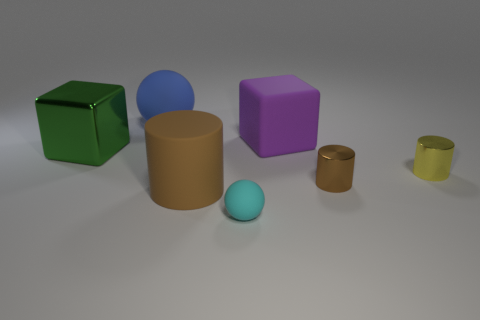Is the number of spheres in front of the large shiny thing greater than the number of big brown objects on the right side of the tiny cyan rubber thing?
Ensure brevity in your answer.  Yes. There is a metallic thing on the left side of the big matte object that is in front of the tiny metallic cylinder in front of the tiny yellow thing; what is its shape?
Provide a short and direct response. Cube. What shape is the thing left of the rubber sphere that is behind the small rubber thing?
Your response must be concise. Cube. Are there any big green objects that have the same material as the large ball?
Offer a very short reply. No. What size is the shiny thing that is the same color as the rubber cylinder?
Provide a short and direct response. Small. How many brown objects are either tiny shiny things or large metallic objects?
Offer a terse response. 1. Are there any other shiny blocks of the same color as the big metal cube?
Make the answer very short. No. What size is the blue object that is made of the same material as the purple cube?
Your response must be concise. Large. What number of cubes are big purple objects or blue things?
Your answer should be very brief. 1. Are there more tiny red metal spheres than brown matte cylinders?
Make the answer very short. No. 